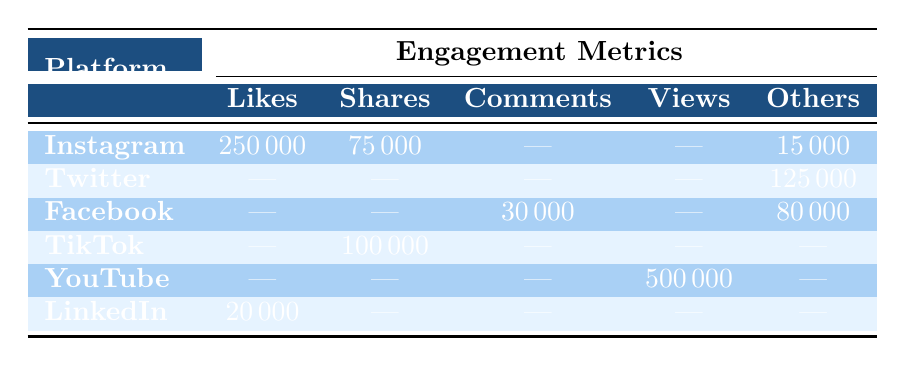What platform had the highest number of likes? The table shows that Instagram had 250,000 likes, which is higher than any other platform listed.
Answer: Instagram How many total shares were recorded across all platforms? From the table, TikTok had 100,000 shares and Instagram had 75,000 shares. Summing these gives us 100,000 + 75,000 = 175,000 total shares across all platforms.
Answer: 175000 Did YouTube have any engagement measures listed outside of views? The table lists only views for YouTube, showing no entries for likes, shares, comments, or other measures. Therefore, the answer is no.
Answer: No What was the total engagement count for Facebook? Facebook had 30,000 comments and 80,000 peak concurrent viewers. Adding these gives 30,000 + 80,000 = 110,000 in total engagement measures for Facebook.
Answer: 110000 Which platform had the lowest engagement type listed? From the table, LinkedIn had only 20,000 likes, which is the lowest compared to other platforms that had higher engagement numbers.
Answer: LinkedIn What is the difference between the total likes on Instagram and LinkedIn? Instagram had 250,000 likes while LinkedIn had 20,000. The difference can be calculated as 250,000 - 20,000 = 230,000.
Answer: 230000 Which engagement type had the highest count across all platforms? The table shows that YouTube had the highest engagement with 500,000 views, which is higher than any other engagement metric listed.
Answer: Views How many engagement measures were recorded for Twitter? The table indicates that Twitter had a total of 125,000 engagement measures counted (75,000 retweets and 50,000 votes), as no other engagement types are listed.
Answer: 125000 What content received the most likes on Instagram? The content with the most likes on Instagram was the "Throwback to Super Bowl victory," totaling 250,000 likes, which is the highest engagement among Instagram posts.
Answer: Super Bowl victory 